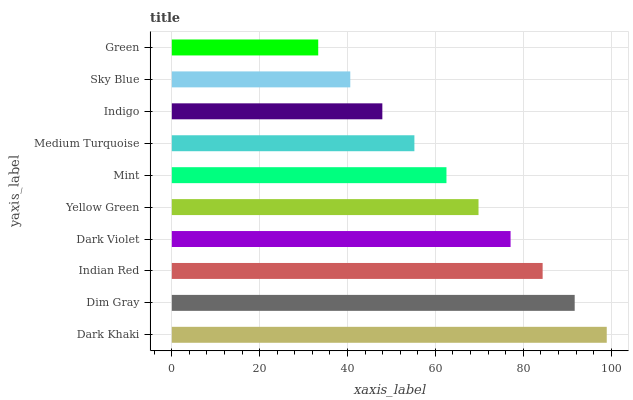Is Green the minimum?
Answer yes or no. Yes. Is Dark Khaki the maximum?
Answer yes or no. Yes. Is Dim Gray the minimum?
Answer yes or no. No. Is Dim Gray the maximum?
Answer yes or no. No. Is Dark Khaki greater than Dim Gray?
Answer yes or no. Yes. Is Dim Gray less than Dark Khaki?
Answer yes or no. Yes. Is Dim Gray greater than Dark Khaki?
Answer yes or no. No. Is Dark Khaki less than Dim Gray?
Answer yes or no. No. Is Yellow Green the high median?
Answer yes or no. Yes. Is Mint the low median?
Answer yes or no. Yes. Is Medium Turquoise the high median?
Answer yes or no. No. Is Dark Violet the low median?
Answer yes or no. No. 